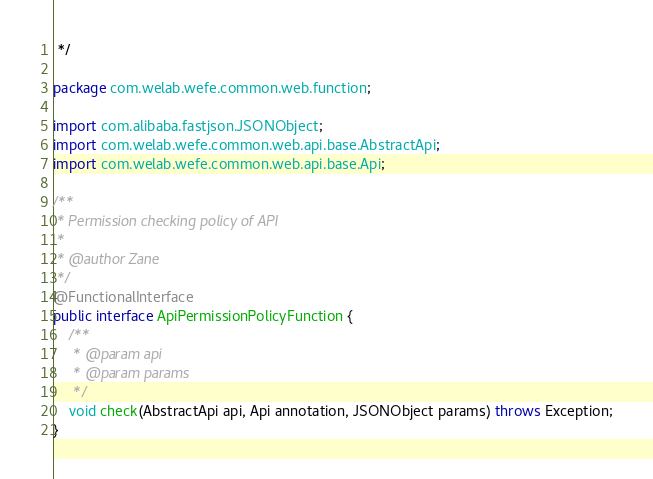<code> <loc_0><loc_0><loc_500><loc_500><_Java_> */

package com.welab.wefe.common.web.function;

import com.alibaba.fastjson.JSONObject;
import com.welab.wefe.common.web.api.base.AbstractApi;
import com.welab.wefe.common.web.api.base.Api;

/**
 * Permission checking policy of API
 *
 * @author Zane
 */
@FunctionalInterface
public interface ApiPermissionPolicyFunction {
    /**
     * @param api
     * @param params
     */
    void check(AbstractApi api, Api annotation, JSONObject params) throws Exception;
}
</code> 